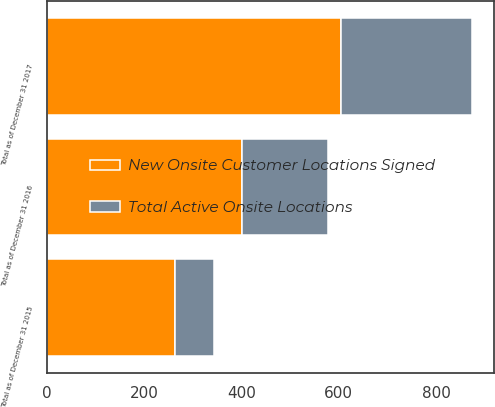Convert chart. <chart><loc_0><loc_0><loc_500><loc_500><stacked_bar_chart><ecel><fcel>Total as of December 31 2015<fcel>Total as of December 31 2016<fcel>Total as of December 31 2017<nl><fcel>Total Active Onsite Locations<fcel>80<fcel>176<fcel>270<nl><fcel>New Onsite Customer Locations Signed<fcel>264<fcel>401<fcel>605<nl></chart> 